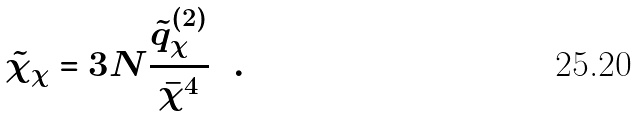Convert formula to latex. <formula><loc_0><loc_0><loc_500><loc_500>\tilde { \chi } _ { \chi } = 3 N \frac { \tilde { q } _ { \chi } ^ { ( 2 ) } } { \bar { \chi } ^ { 4 } } \ \ .</formula> 